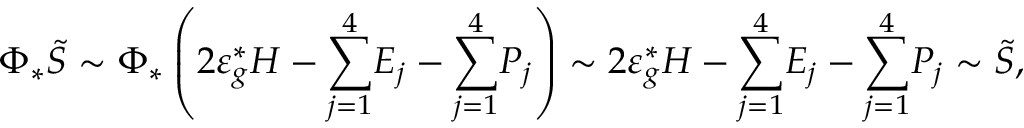Convert formula to latex. <formula><loc_0><loc_0><loc_500><loc_500>\Phi _ { * } \widetilde { S } \sim \Phi _ { * } \left ( 2 \varepsilon _ { g } ^ { * } H - \underset { j = 1 } { \overset { 4 } { \sum } } E _ { j } - \underset { j = 1 } { \overset { 4 } { \sum } } P _ { j } \right ) \sim 2 \varepsilon _ { g } ^ { * } H - \underset { j = 1 } { \overset { 4 } { \sum } } E _ { j } - \underset { j = 1 } { \overset { 4 } { \sum } } P _ { j } \sim \widetilde { S } ,</formula> 